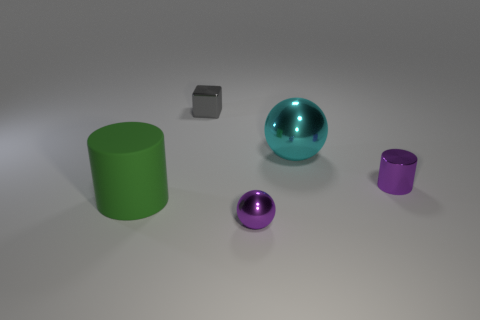Add 4 tiny yellow metallic objects. How many objects exist? 9 Subtract 0 purple cubes. How many objects are left? 5 Subtract all blocks. How many objects are left? 4 Subtract all brown matte cubes. Subtract all green cylinders. How many objects are left? 4 Add 1 big cyan metal things. How many big cyan metal things are left? 2 Add 4 green matte things. How many green matte things exist? 5 